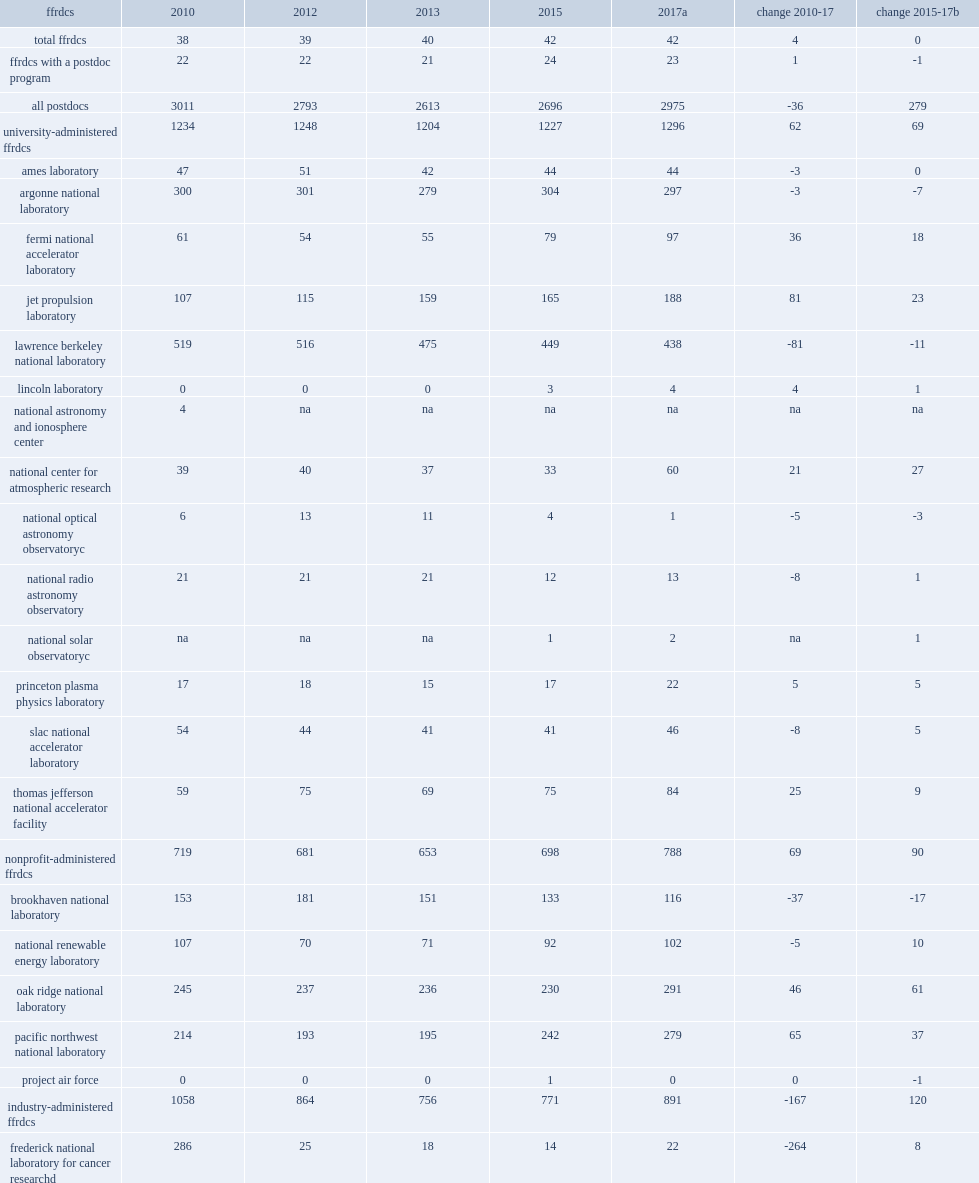Although the number of postdocs working at ffrdcs declined earlier in the decade, it has recently increased, what is the count of postdocs in 2010? 3011.0. What was the number of ffrdcs increased in 2010? 38.0. What was the number of ffrdcs increased in 2017? 42.0. What was the number of ffrdcs with postdoc programs fluctuated in 2013? 21.0. What was the number of ffrdcs with postdoc programs fluctuated in 2015? 24.0. 